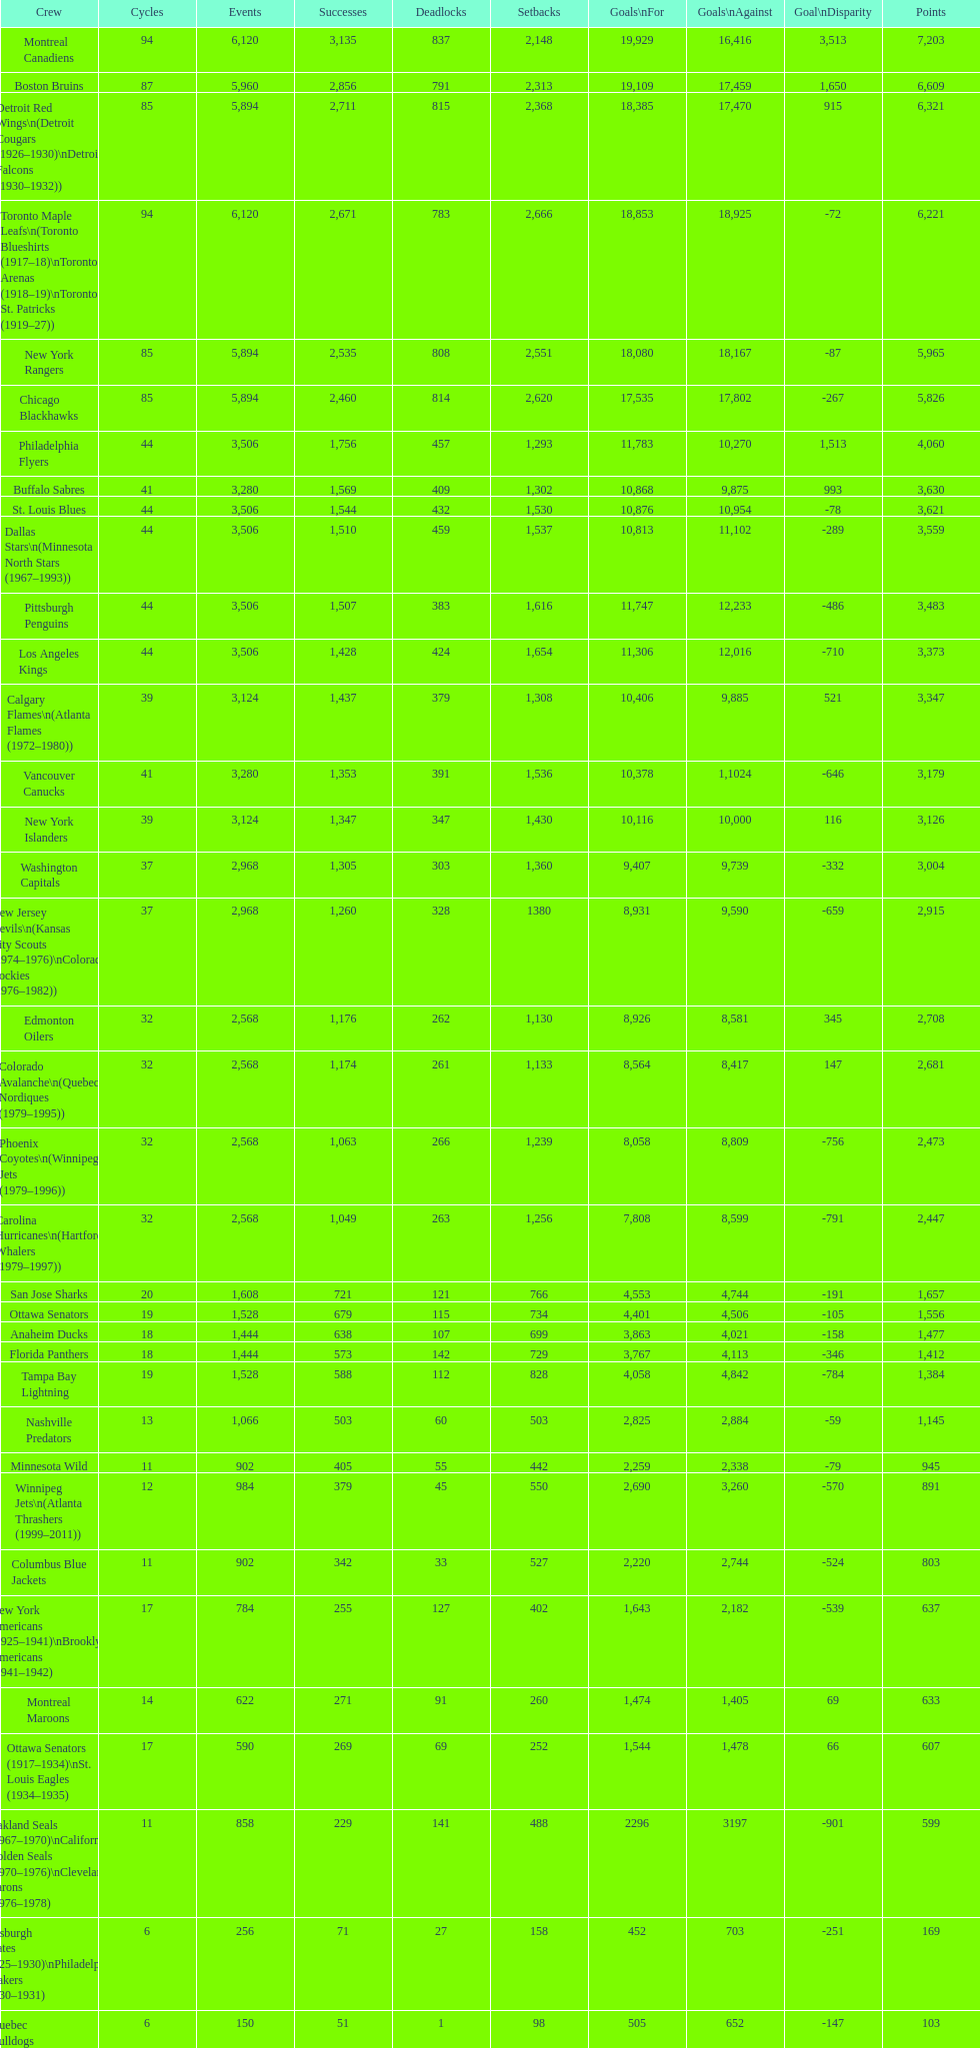How many total points has the lost angeles kings scored? 3,373. 